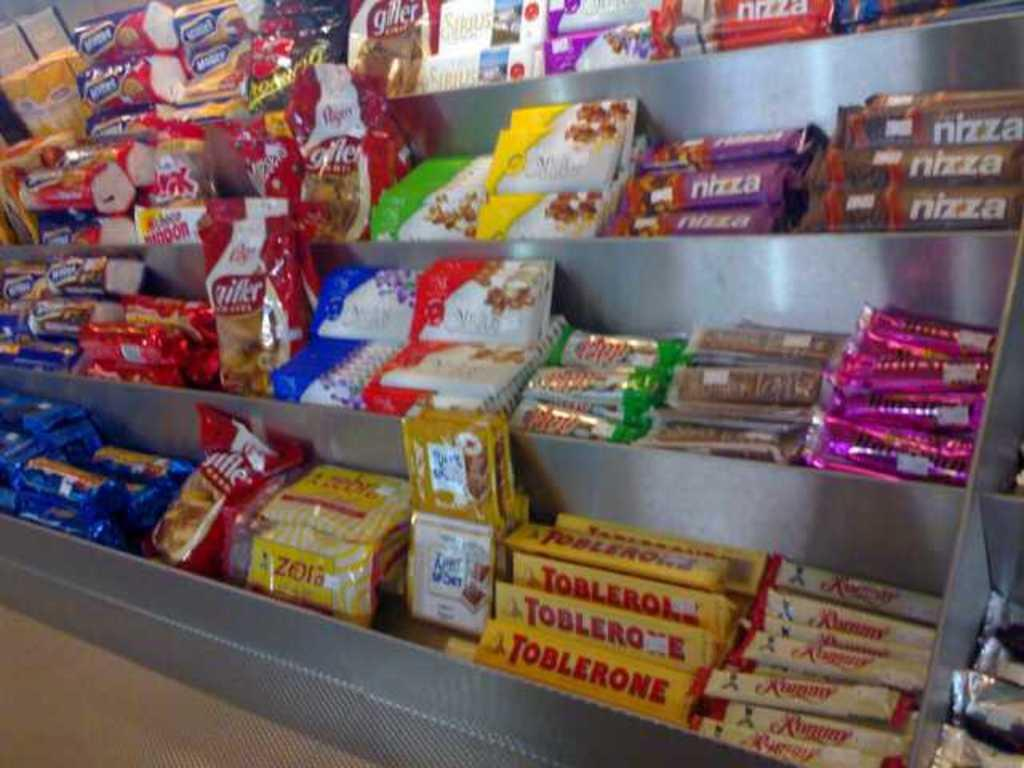<image>
Render a clear and concise summary of the photo. Store full of different candy including Nizza and Toblerone. 